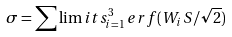Convert formula to latex. <formula><loc_0><loc_0><loc_500><loc_500>\sigma = \sum \lim i t s ^ { 3 } _ { i = 1 } \, e r f ( W _ { i } \, S / \sqrt { 2 } )</formula> 